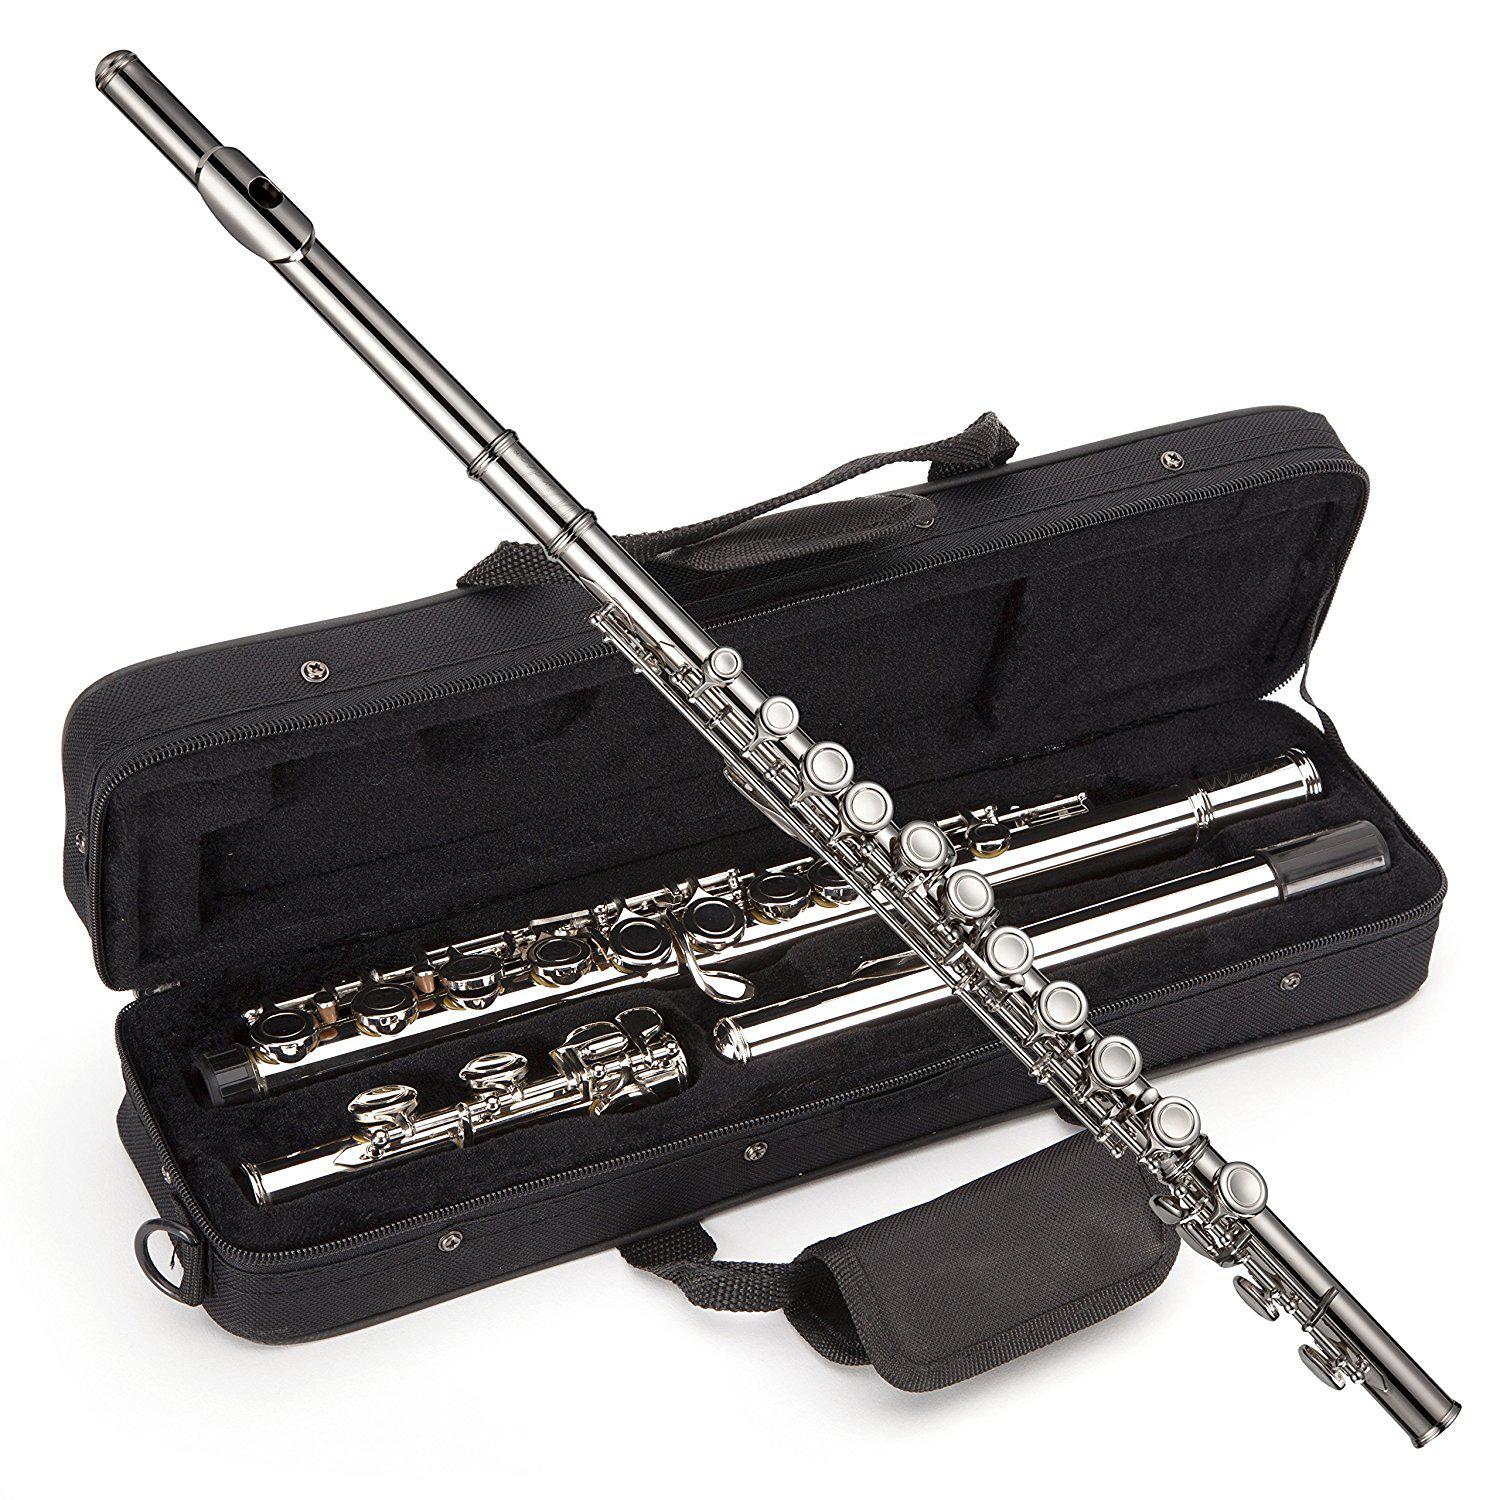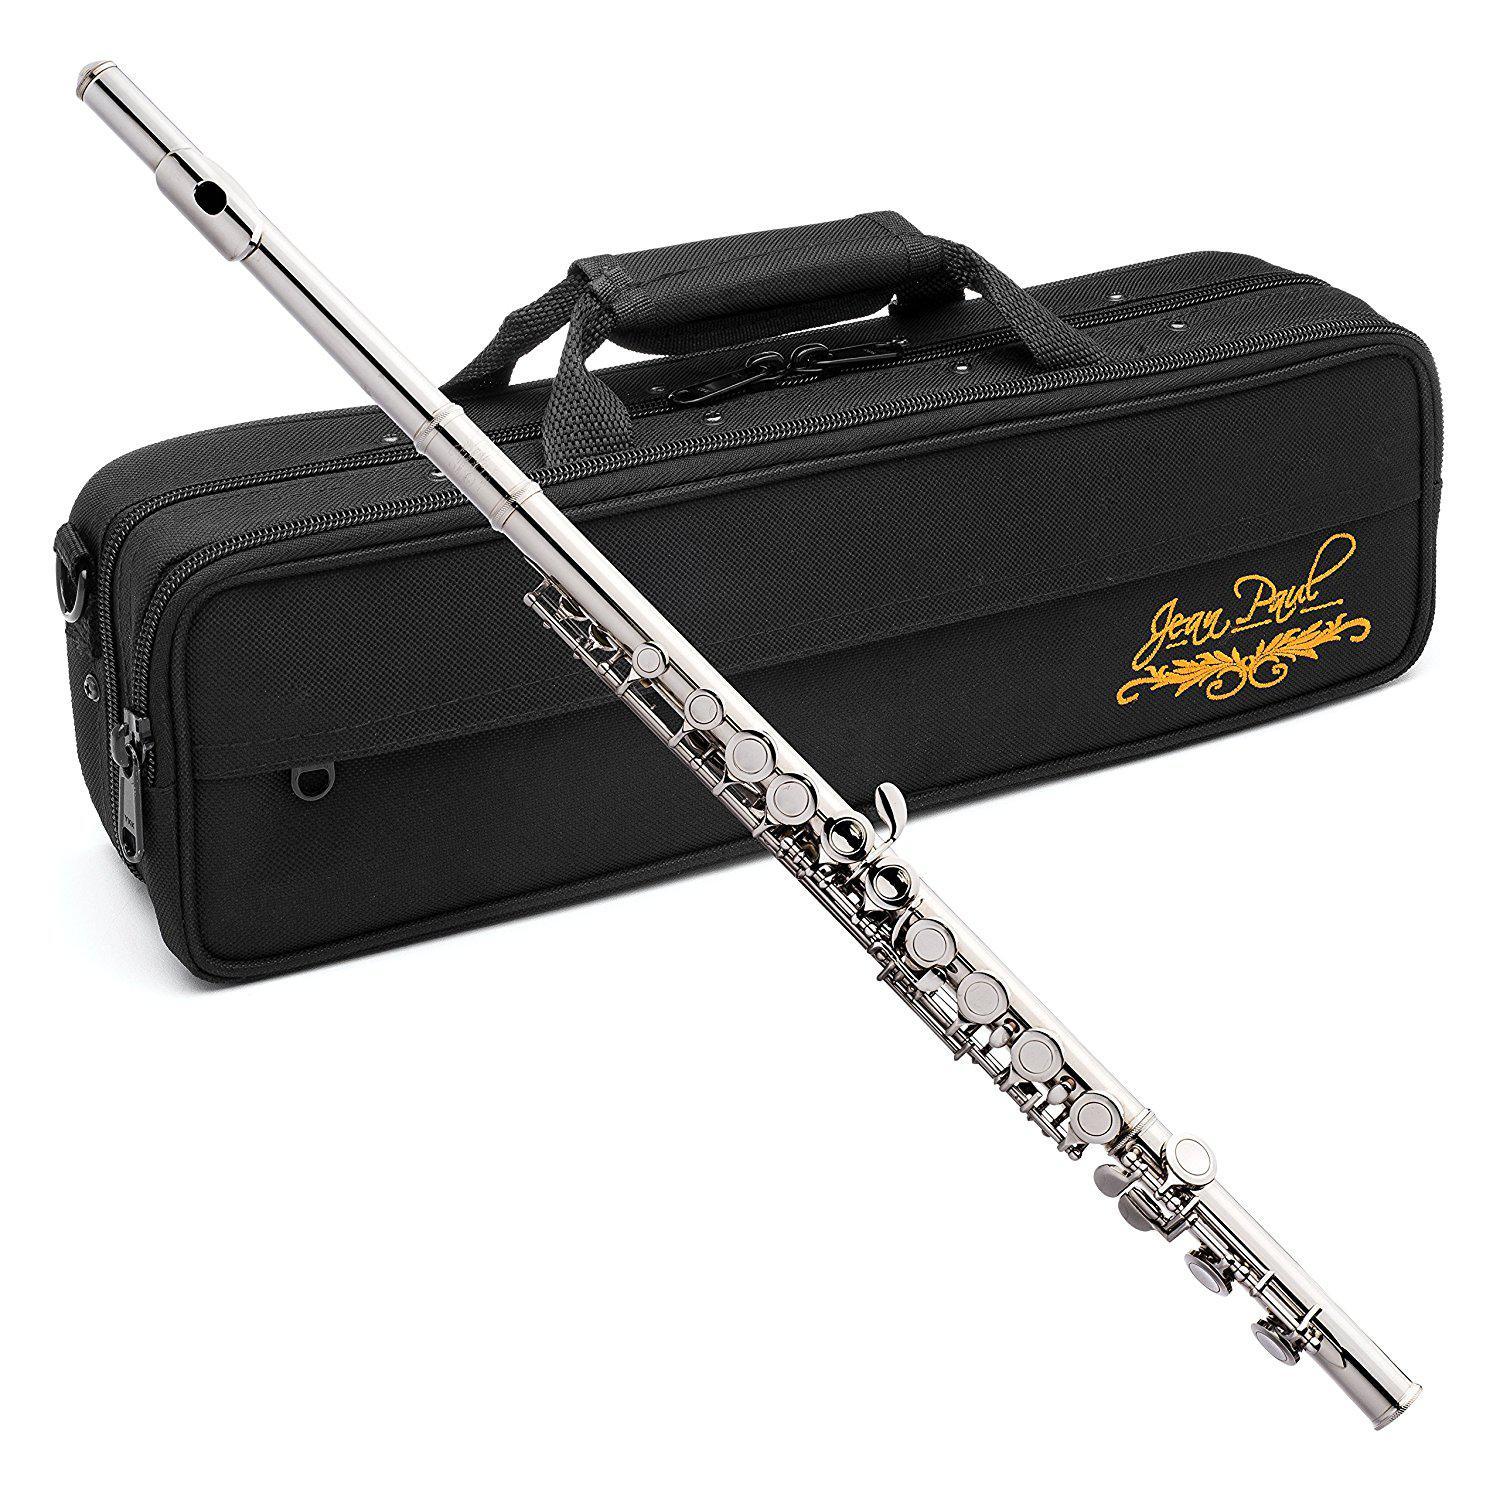The first image is the image on the left, the second image is the image on the right. For the images shown, is this caption "One of the instrument cases is completely closed." true? Answer yes or no. Yes. The first image is the image on the left, the second image is the image on the right. Analyze the images presented: Is the assertion "In the image pair there are two flutes propped over their carrying cases" valid? Answer yes or no. Yes. 